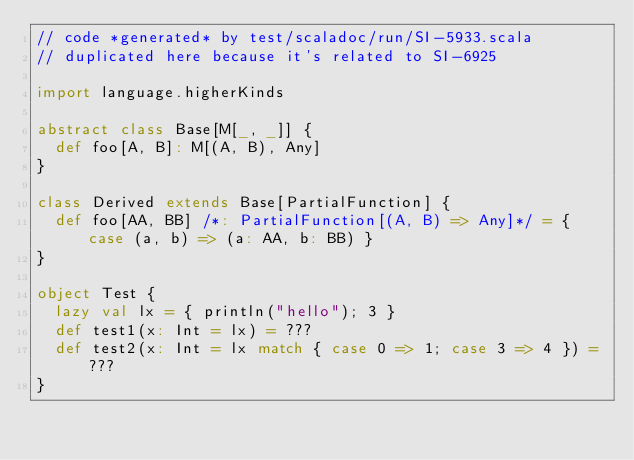<code> <loc_0><loc_0><loc_500><loc_500><_Scala_>// code *generated* by test/scaladoc/run/SI-5933.scala
// duplicated here because it's related to SI-6925

import language.higherKinds

abstract class Base[M[_, _]] {
  def foo[A, B]: M[(A, B), Any]
}

class Derived extends Base[PartialFunction] {
  def foo[AA, BB] /*: PartialFunction[(A, B) => Any]*/ = { case (a, b) => (a: AA, b: BB) }
}

object Test {
  lazy val lx = { println("hello"); 3 }
  def test1(x: Int = lx) = ???
  def test2(x: Int = lx match { case 0 => 1; case 3 => 4 }) = ???
}
</code> 